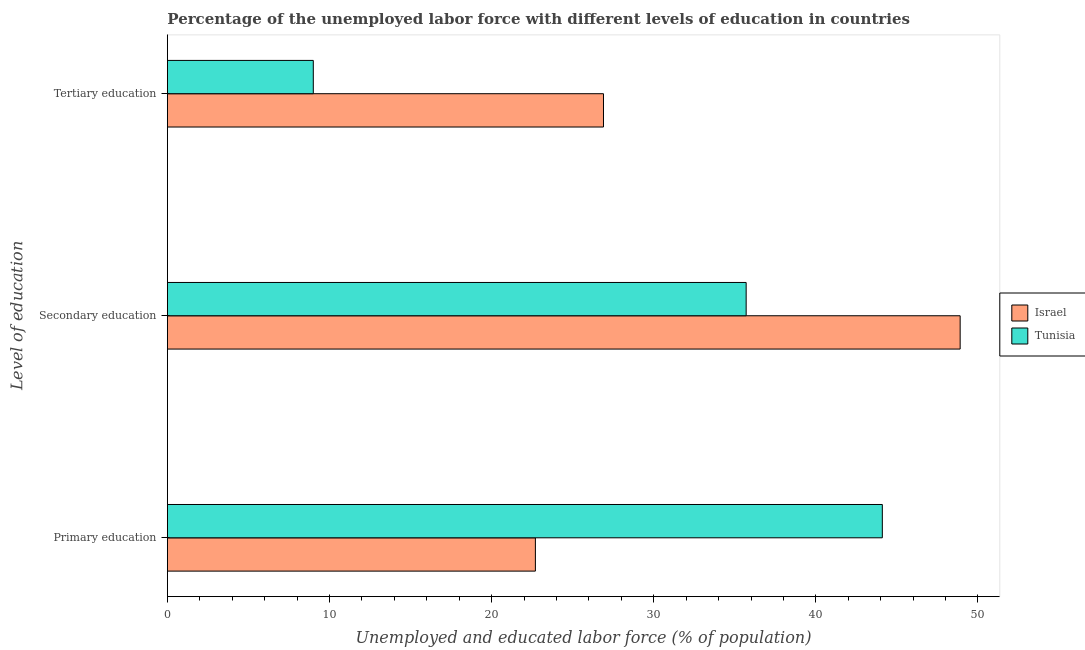How many different coloured bars are there?
Ensure brevity in your answer.  2. Are the number of bars on each tick of the Y-axis equal?
Keep it short and to the point. Yes. How many bars are there on the 1st tick from the bottom?
Make the answer very short. 2. What is the label of the 1st group of bars from the top?
Offer a very short reply. Tertiary education. Across all countries, what is the maximum percentage of labor force who received tertiary education?
Make the answer very short. 26.9. Across all countries, what is the minimum percentage of labor force who received secondary education?
Offer a very short reply. 35.7. In which country was the percentage of labor force who received secondary education minimum?
Make the answer very short. Tunisia. What is the total percentage of labor force who received tertiary education in the graph?
Keep it short and to the point. 35.9. What is the difference between the percentage of labor force who received tertiary education in Tunisia and that in Israel?
Keep it short and to the point. -17.9. What is the difference between the percentage of labor force who received tertiary education in Tunisia and the percentage of labor force who received secondary education in Israel?
Provide a short and direct response. -39.9. What is the average percentage of labor force who received secondary education per country?
Provide a short and direct response. 42.3. What is the difference between the percentage of labor force who received primary education and percentage of labor force who received secondary education in Tunisia?
Offer a very short reply. 8.4. What is the ratio of the percentage of labor force who received tertiary education in Tunisia to that in Israel?
Offer a very short reply. 0.33. Is the difference between the percentage of labor force who received tertiary education in Tunisia and Israel greater than the difference between the percentage of labor force who received secondary education in Tunisia and Israel?
Keep it short and to the point. No. What is the difference between the highest and the second highest percentage of labor force who received primary education?
Make the answer very short. 21.4. What is the difference between the highest and the lowest percentage of labor force who received tertiary education?
Your answer should be compact. 17.9. In how many countries, is the percentage of labor force who received primary education greater than the average percentage of labor force who received primary education taken over all countries?
Your answer should be compact. 1. What does the 1st bar from the top in Primary education represents?
Give a very brief answer. Tunisia. What does the 2nd bar from the bottom in Tertiary education represents?
Provide a short and direct response. Tunisia. Is it the case that in every country, the sum of the percentage of labor force who received primary education and percentage of labor force who received secondary education is greater than the percentage of labor force who received tertiary education?
Your response must be concise. Yes. Are all the bars in the graph horizontal?
Provide a short and direct response. Yes. How many countries are there in the graph?
Your response must be concise. 2. What is the difference between two consecutive major ticks on the X-axis?
Make the answer very short. 10. Does the graph contain any zero values?
Your answer should be compact. No. Where does the legend appear in the graph?
Your answer should be compact. Center right. How are the legend labels stacked?
Your answer should be compact. Vertical. What is the title of the graph?
Make the answer very short. Percentage of the unemployed labor force with different levels of education in countries. Does "Tanzania" appear as one of the legend labels in the graph?
Give a very brief answer. No. What is the label or title of the X-axis?
Your response must be concise. Unemployed and educated labor force (% of population). What is the label or title of the Y-axis?
Your answer should be very brief. Level of education. What is the Unemployed and educated labor force (% of population) of Israel in Primary education?
Offer a very short reply. 22.7. What is the Unemployed and educated labor force (% of population) in Tunisia in Primary education?
Your answer should be very brief. 44.1. What is the Unemployed and educated labor force (% of population) in Israel in Secondary education?
Your response must be concise. 48.9. What is the Unemployed and educated labor force (% of population) in Tunisia in Secondary education?
Provide a succinct answer. 35.7. What is the Unemployed and educated labor force (% of population) of Israel in Tertiary education?
Give a very brief answer. 26.9. What is the Unemployed and educated labor force (% of population) of Tunisia in Tertiary education?
Provide a short and direct response. 9. Across all Level of education, what is the maximum Unemployed and educated labor force (% of population) of Israel?
Provide a succinct answer. 48.9. Across all Level of education, what is the maximum Unemployed and educated labor force (% of population) of Tunisia?
Ensure brevity in your answer.  44.1. Across all Level of education, what is the minimum Unemployed and educated labor force (% of population) in Israel?
Provide a short and direct response. 22.7. What is the total Unemployed and educated labor force (% of population) in Israel in the graph?
Provide a short and direct response. 98.5. What is the total Unemployed and educated labor force (% of population) of Tunisia in the graph?
Keep it short and to the point. 88.8. What is the difference between the Unemployed and educated labor force (% of population) in Israel in Primary education and that in Secondary education?
Your response must be concise. -26.2. What is the difference between the Unemployed and educated labor force (% of population) of Israel in Primary education and that in Tertiary education?
Offer a terse response. -4.2. What is the difference between the Unemployed and educated labor force (% of population) in Tunisia in Primary education and that in Tertiary education?
Give a very brief answer. 35.1. What is the difference between the Unemployed and educated labor force (% of population) in Tunisia in Secondary education and that in Tertiary education?
Ensure brevity in your answer.  26.7. What is the difference between the Unemployed and educated labor force (% of population) in Israel in Primary education and the Unemployed and educated labor force (% of population) in Tunisia in Secondary education?
Ensure brevity in your answer.  -13. What is the difference between the Unemployed and educated labor force (% of population) of Israel in Primary education and the Unemployed and educated labor force (% of population) of Tunisia in Tertiary education?
Provide a succinct answer. 13.7. What is the difference between the Unemployed and educated labor force (% of population) in Israel in Secondary education and the Unemployed and educated labor force (% of population) in Tunisia in Tertiary education?
Offer a terse response. 39.9. What is the average Unemployed and educated labor force (% of population) of Israel per Level of education?
Your response must be concise. 32.83. What is the average Unemployed and educated labor force (% of population) in Tunisia per Level of education?
Offer a terse response. 29.6. What is the difference between the Unemployed and educated labor force (% of population) in Israel and Unemployed and educated labor force (% of population) in Tunisia in Primary education?
Provide a succinct answer. -21.4. What is the difference between the Unemployed and educated labor force (% of population) in Israel and Unemployed and educated labor force (% of population) in Tunisia in Secondary education?
Make the answer very short. 13.2. What is the ratio of the Unemployed and educated labor force (% of population) in Israel in Primary education to that in Secondary education?
Offer a very short reply. 0.46. What is the ratio of the Unemployed and educated labor force (% of population) of Tunisia in Primary education to that in Secondary education?
Keep it short and to the point. 1.24. What is the ratio of the Unemployed and educated labor force (% of population) of Israel in Primary education to that in Tertiary education?
Provide a short and direct response. 0.84. What is the ratio of the Unemployed and educated labor force (% of population) in Israel in Secondary education to that in Tertiary education?
Keep it short and to the point. 1.82. What is the ratio of the Unemployed and educated labor force (% of population) of Tunisia in Secondary education to that in Tertiary education?
Offer a terse response. 3.97. What is the difference between the highest and the lowest Unemployed and educated labor force (% of population) in Israel?
Offer a terse response. 26.2. What is the difference between the highest and the lowest Unemployed and educated labor force (% of population) in Tunisia?
Provide a short and direct response. 35.1. 